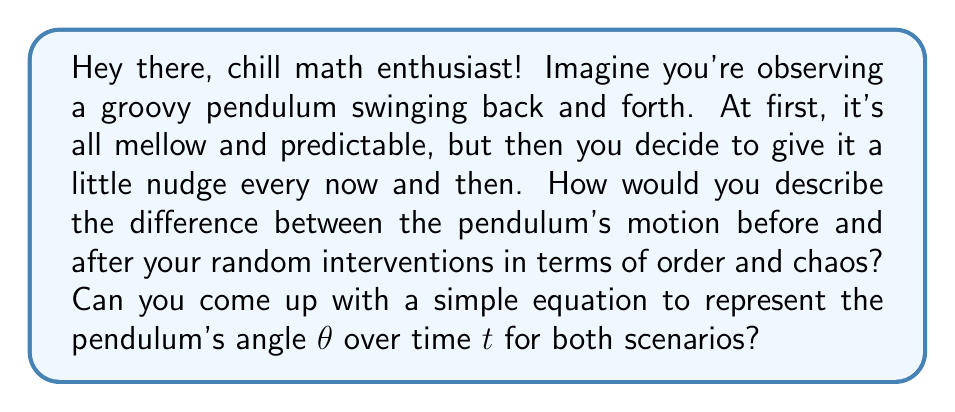Could you help me with this problem? Alright, let's break this down step-by-step:

1. Before the interventions:
   The pendulum's motion is orderly and predictable. It follows a simple harmonic motion, which can be described by the equation:

   $$\theta(t) = A \cos(\omega t + \phi)$$

   Where:
   - $A$ is the amplitude (maximum angle)
   - $\omega$ is the angular frequency
   - $\phi$ is the phase shift

   This equation represents order in the system.

2. After the interventions:
   The random nudges introduce chaos into the system. The motion becomes unpredictable and sensitive to initial conditions. We can modify our equation to include a chaotic term:

   $$\theta(t) = A \cos(\omega t + \phi) + \epsilon f(t)$$

   Where:
   - $\epsilon$ is a small parameter representing the strength of the chaos
   - $f(t)$ is a chaotic function, e.g., the logistic map: $f(t) = r f(t-1)(1-f(t-1))$

3. Comparing order and chaos:
   - Ordered system: Predictable, repeating pattern
   - Chaotic system: Unpredictable, sensitive to initial conditions

4. In natural systems:
   - Order: Seasons, planetary orbits, crystal structures
   - Chaos: Weather patterns, population dynamics, fluid turbulence

The key difference is that small changes in initial conditions lead to drastically different outcomes in chaotic systems, while ordered systems remain relatively stable.
Answer: $\theta(t) = A \cos(\omega t + \phi)$ (order); $\theta(t) = A \cos(\omega t + \phi) + \epsilon f(t)$ (chaos) 